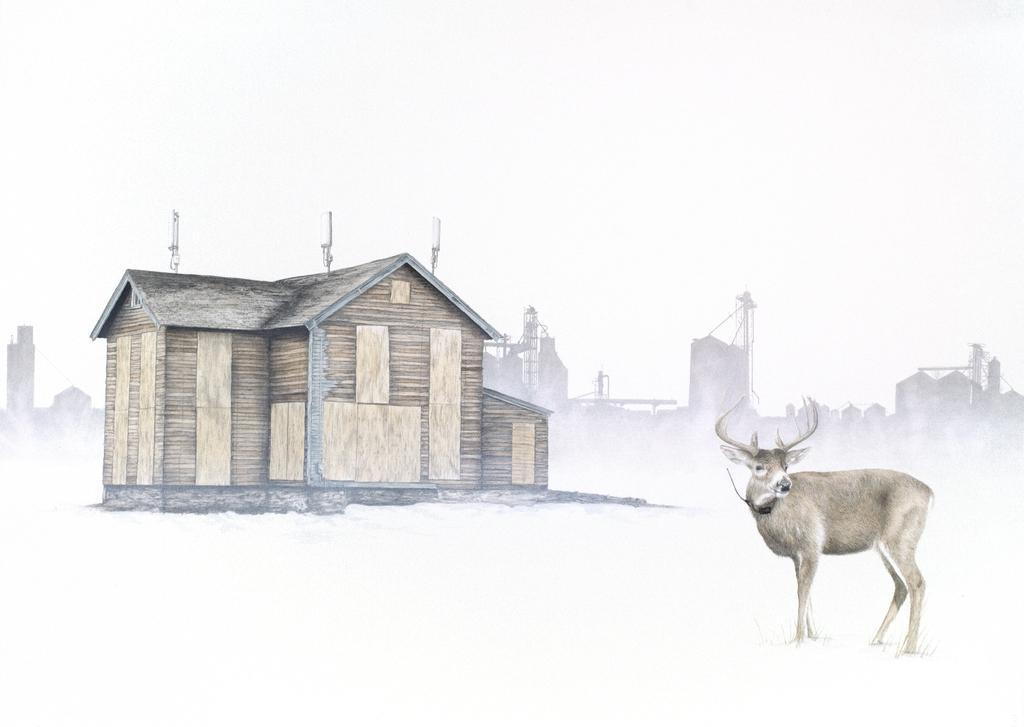Could you give a brief overview of what you see in this image? In the image I can see a house and an animal. In the background I can see buildings. The background of the image is white in color. 